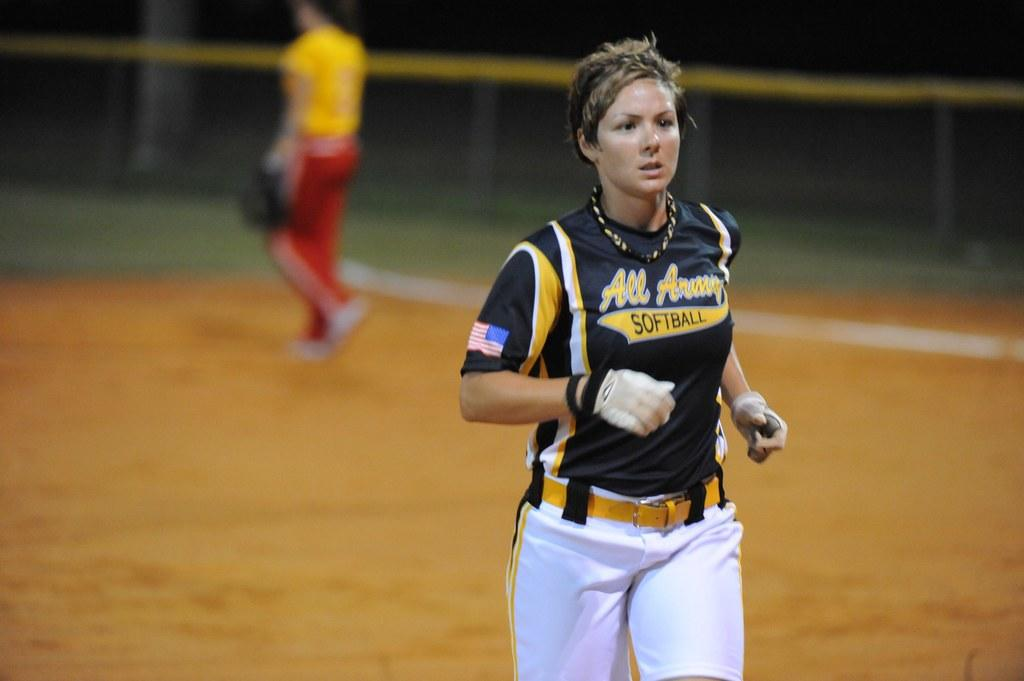<image>
Describe the image concisely. a woman in an all army softball jersey running down the field 